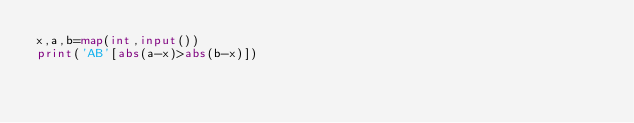<code> <loc_0><loc_0><loc_500><loc_500><_Python_>x,a,b=map(int,input())
print('AB'[abs(a-x)>abs(b-x)])</code> 